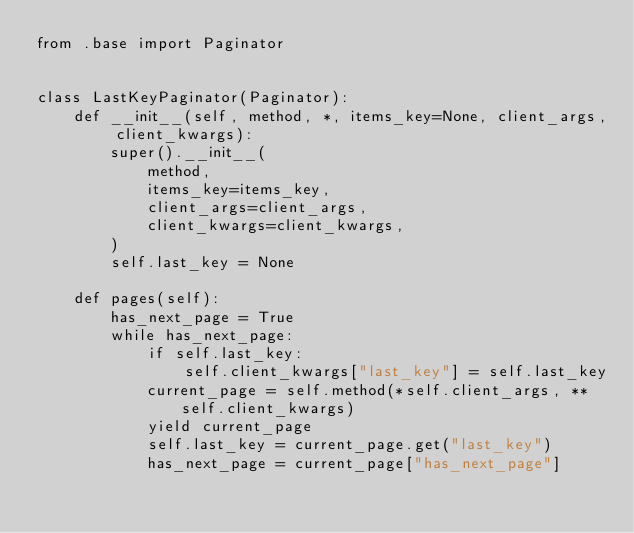Convert code to text. <code><loc_0><loc_0><loc_500><loc_500><_Python_>from .base import Paginator


class LastKeyPaginator(Paginator):
    def __init__(self, method, *, items_key=None, client_args, client_kwargs):
        super().__init__(
            method,
            items_key=items_key,
            client_args=client_args,
            client_kwargs=client_kwargs,
        )
        self.last_key = None

    def pages(self):
        has_next_page = True
        while has_next_page:
            if self.last_key:
                self.client_kwargs["last_key"] = self.last_key
            current_page = self.method(*self.client_args, **self.client_kwargs)
            yield current_page
            self.last_key = current_page.get("last_key")
            has_next_page = current_page["has_next_page"]
</code> 